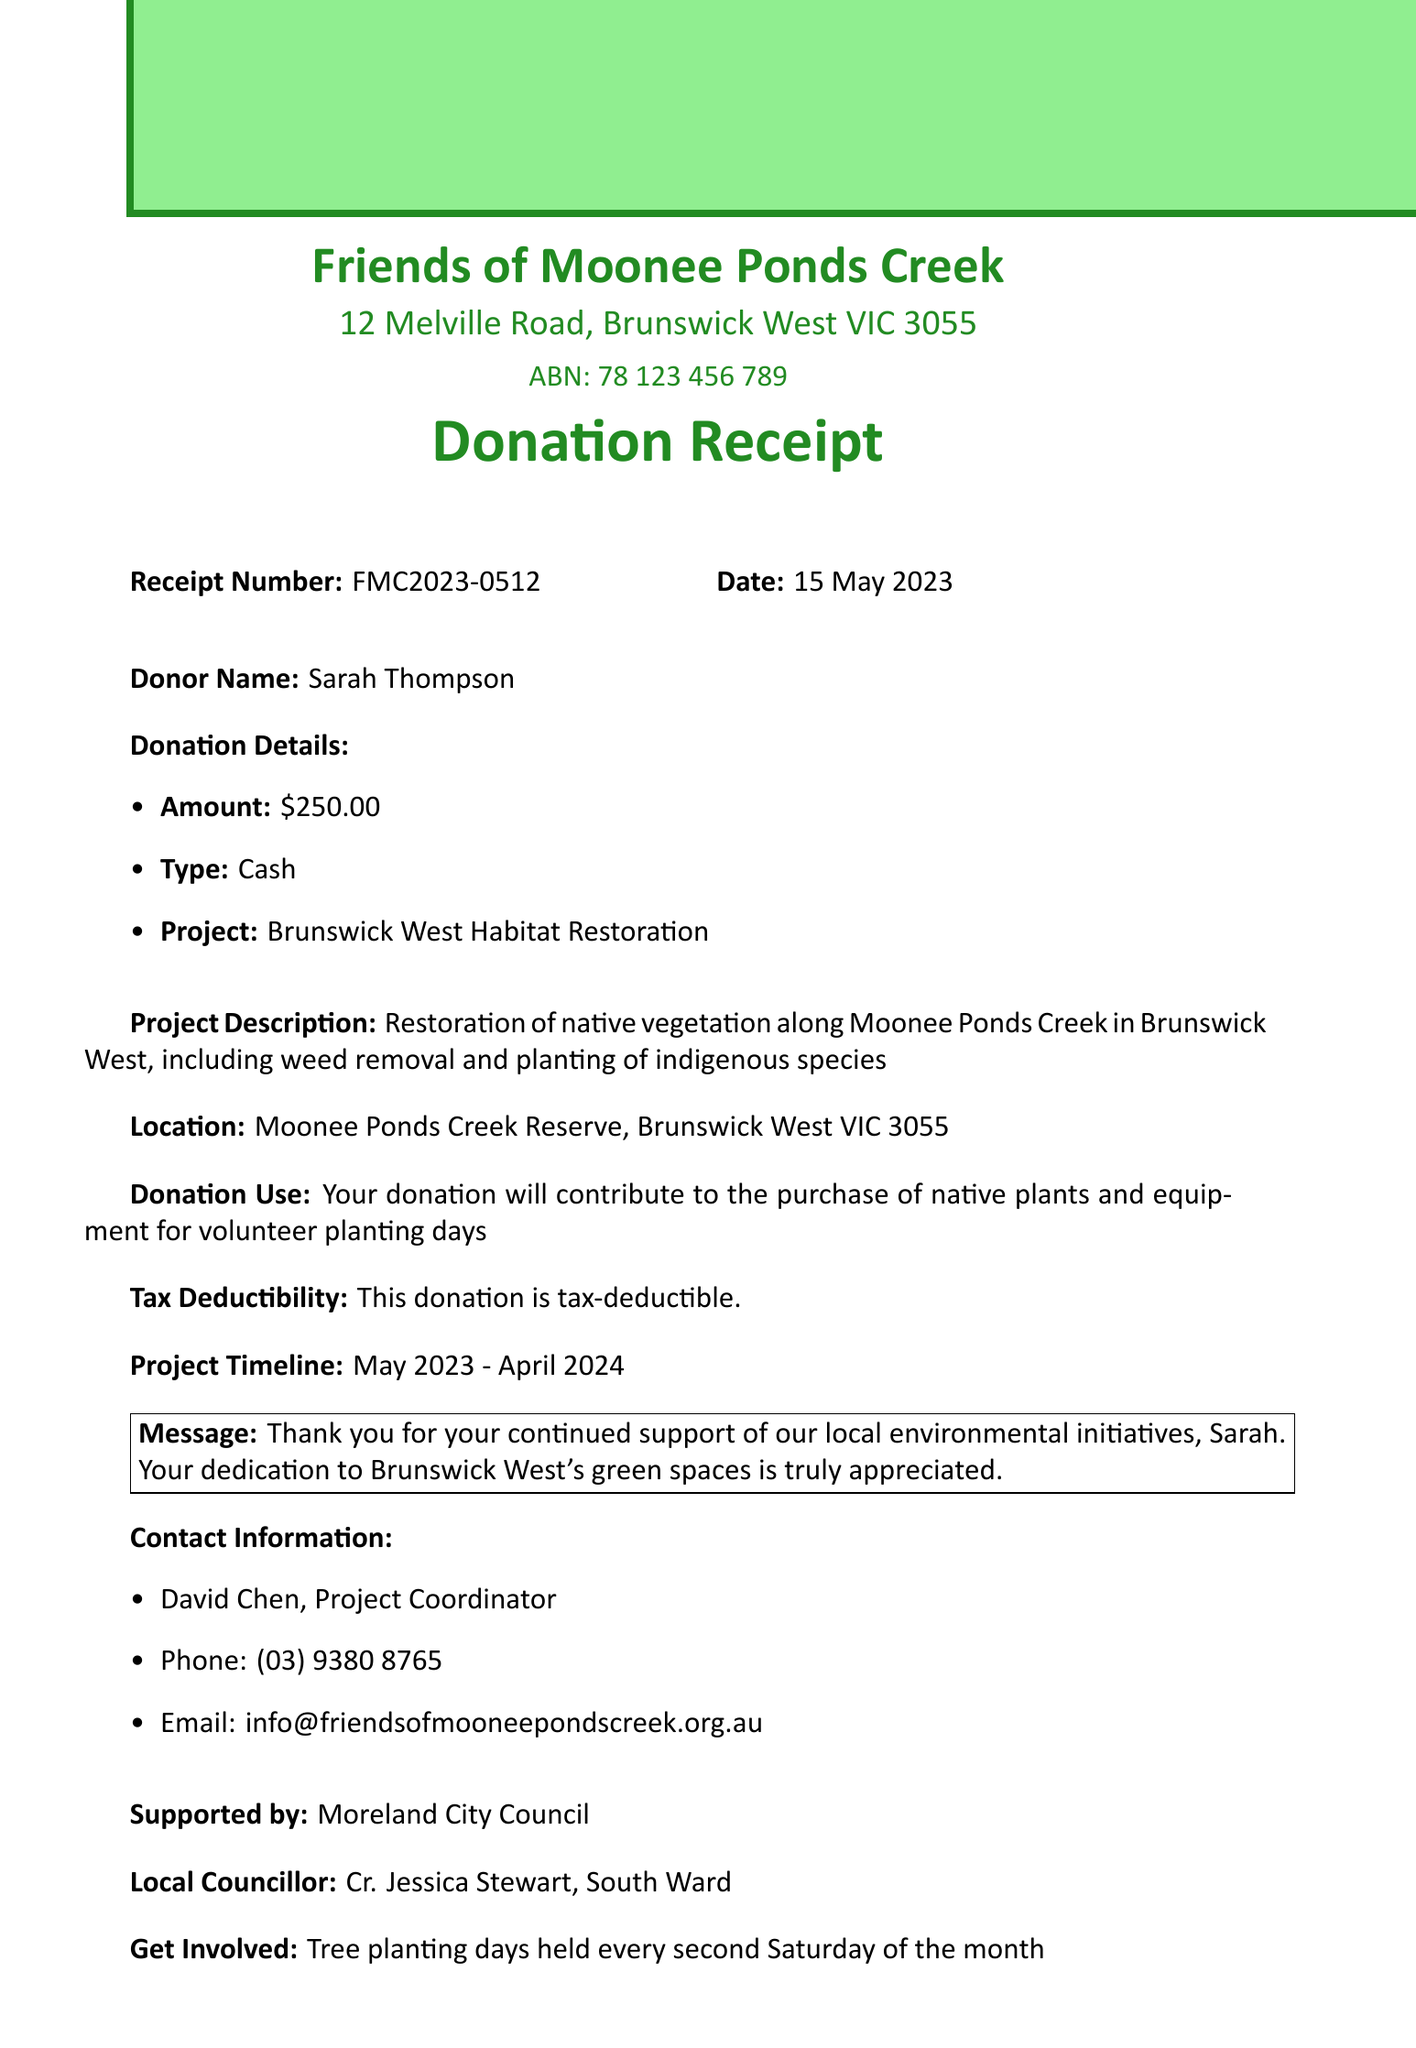What is the name of the organization? The organization is named "Friends of Moonee Ponds Creek" as stated at the top of the document.
Answer: Friends of Moonee Ponds Creek What is the donation amount? The document specifies that the donation amount made by the donor is $250.00.
Answer: $250.00 What is the project location? The project location is detailed in the document as Moonee Ponds Creek Reserve, Brunswick West VIC 3055.
Answer: Moonee Ponds Creek Reserve, Brunswick West VIC 3055 Who is the contact person for the project? The contact person for the project is listed as David Chen, Project Coordinator.
Answer: David Chen When is the next community meeting? The next community meeting is scheduled for June 5, 2023, at 7:00 PM.
Answer: June 5, 2023, 7:00 PM What will the donation be used for? The document mentions that the donation will contribute to the purchase of native plants and equipment for volunteer planting days.
Answer: Purchase of native plants and equipment What is the project timeline? The project timeline is stated as May 2023 - April 2024.
Answer: May 2023 - April 2024 Who endorses this project? The document indicates that the project is supported by Moreland City Council.
Answer: Moreland City Council What message is written to the donor? The document includes a message thanking Sarah for her support of local environmental initiatives.
Answer: Thank you for your continued support of our local environmental initiatives, Sarah 